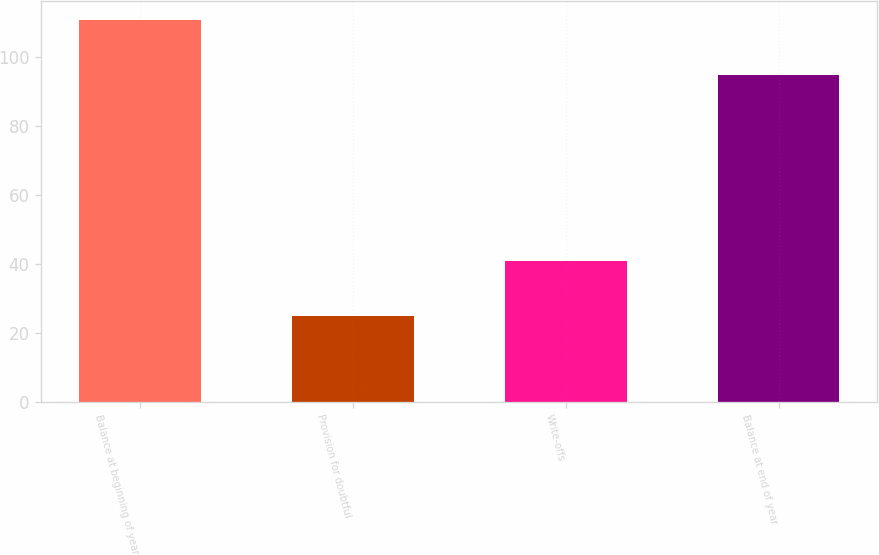<chart> <loc_0><loc_0><loc_500><loc_500><bar_chart><fcel>Balance at beginning of year<fcel>Provision for doubtful<fcel>Write-offs<fcel>Balance at end of year<nl><fcel>111<fcel>25<fcel>41<fcel>95<nl></chart> 